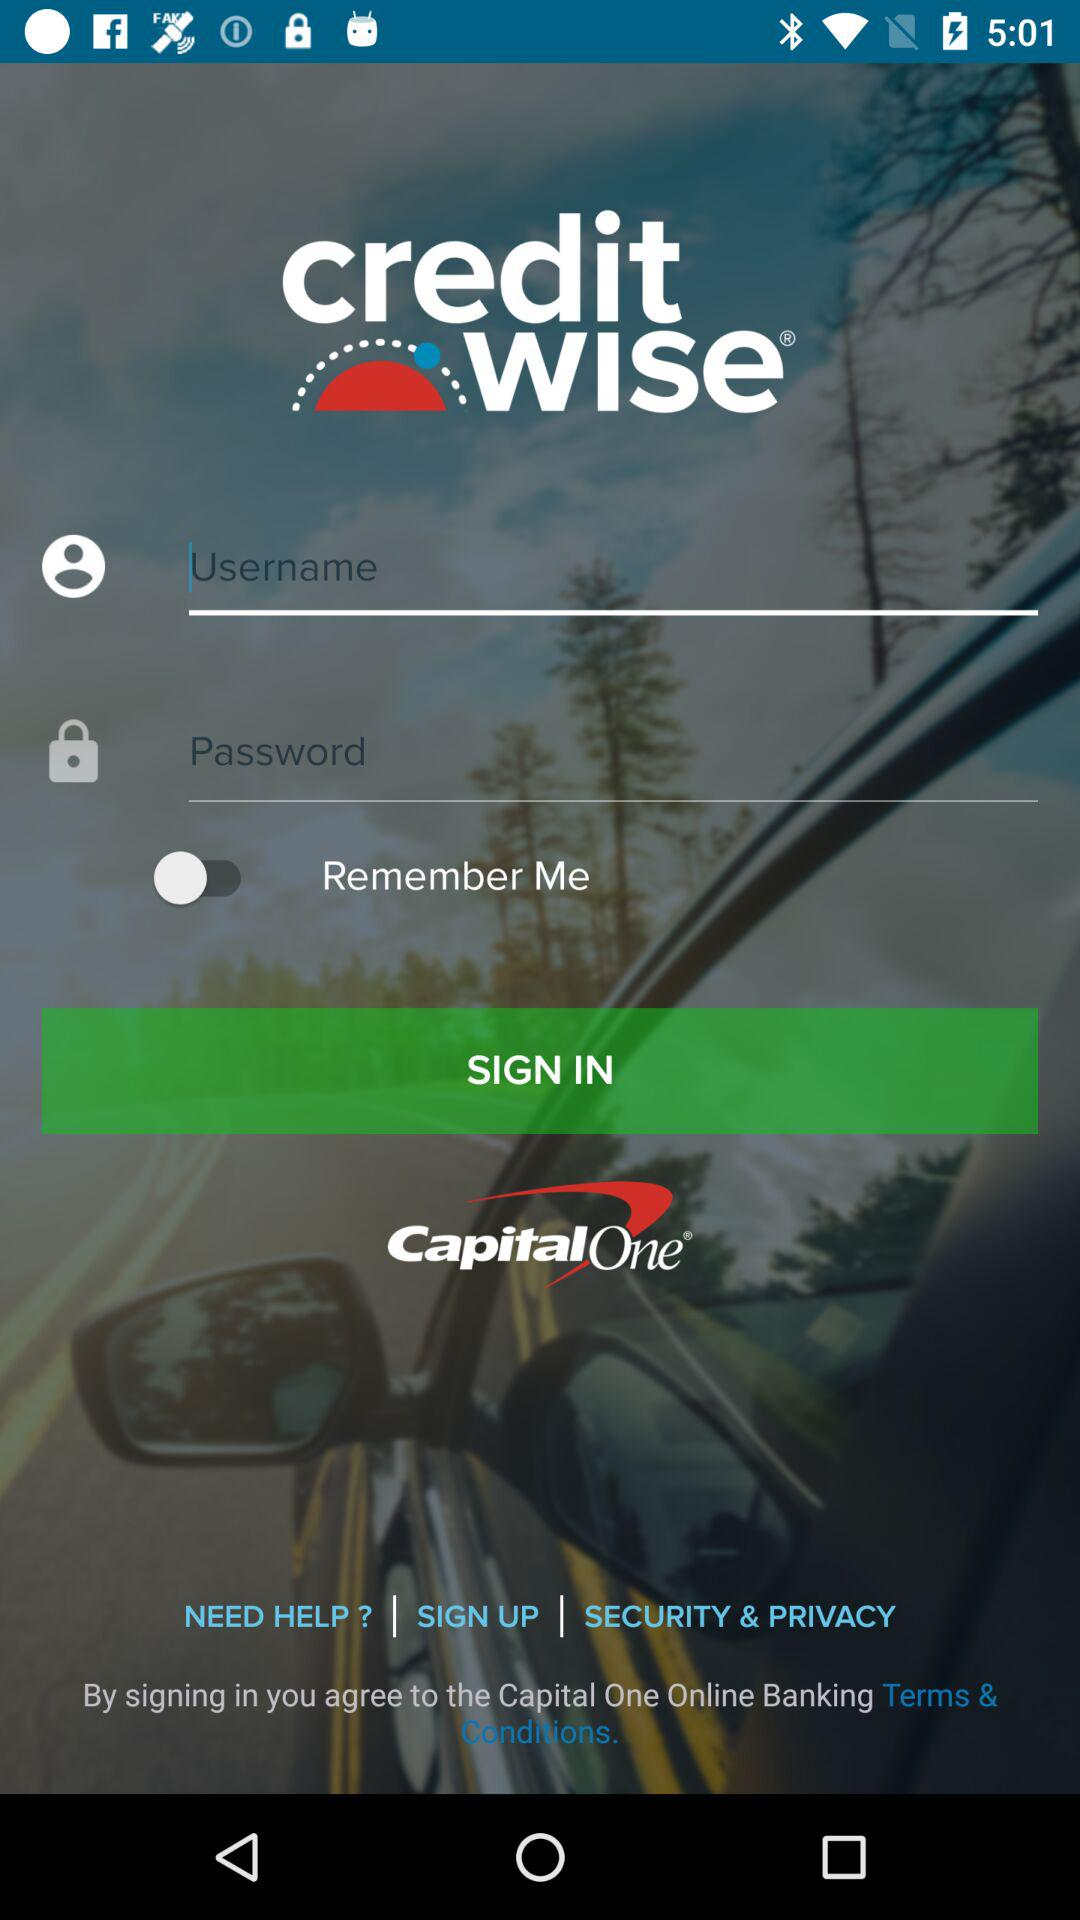How many text fields are there in the sign in form?
Answer the question using a single word or phrase. 2 